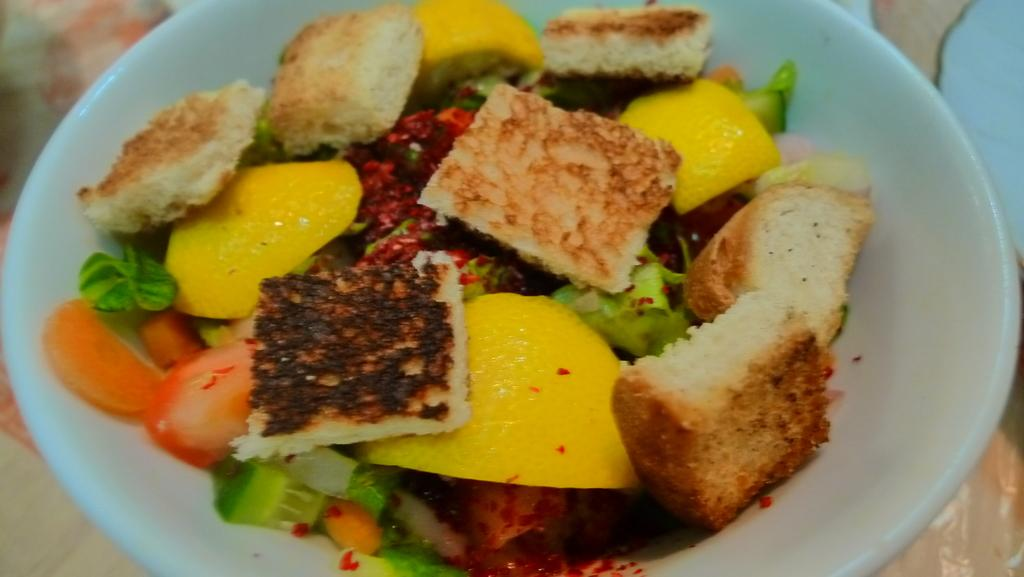What type of items are present on the plate in the image? There are eatable items in the image. How are the eatable items arranged or presented? The eatable items are placed on a plate. Where is the plate with the eatable items located? The plate with the eatable items is kept on a table. What is the title of the book that is being read by the person in the image? There is no person or book present in the image; it only features eatable items on a plate. What is the weather like in the image? The image does not provide any information about the weather. 